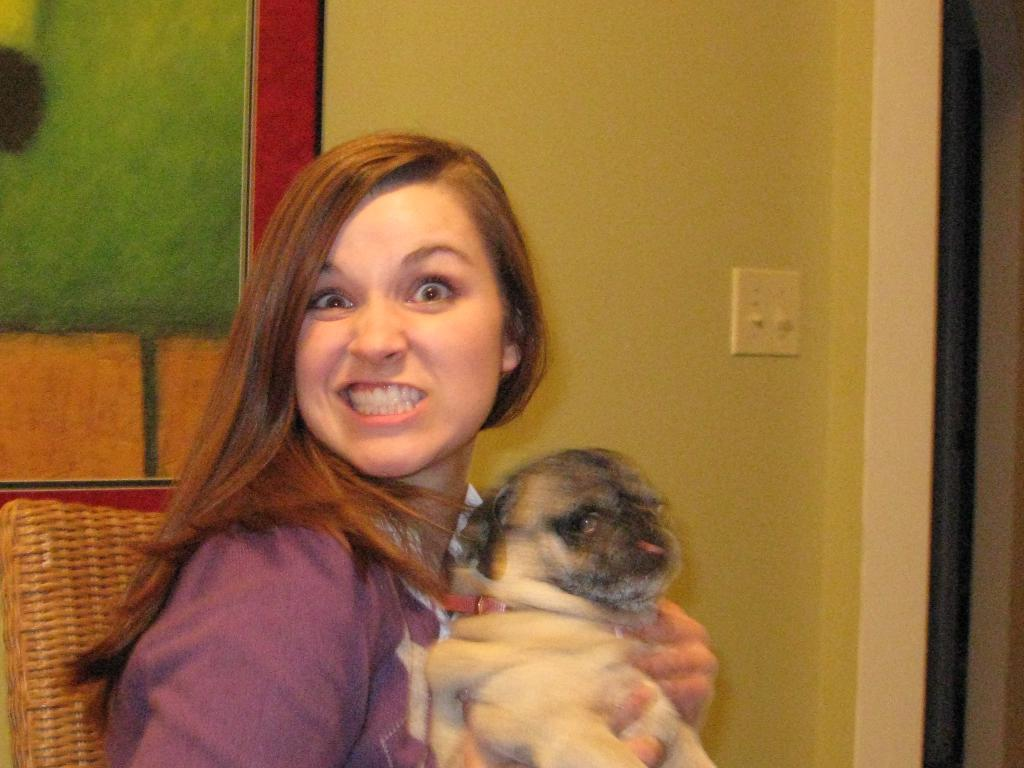Who is the main subject in the image? There is a girl in the image. What is the girl holding in the image? The girl is holding a dog. What type of theory is the girl discussing with the horses in the image? There are no horses present in the image, and the girl is not discussing any theories. 